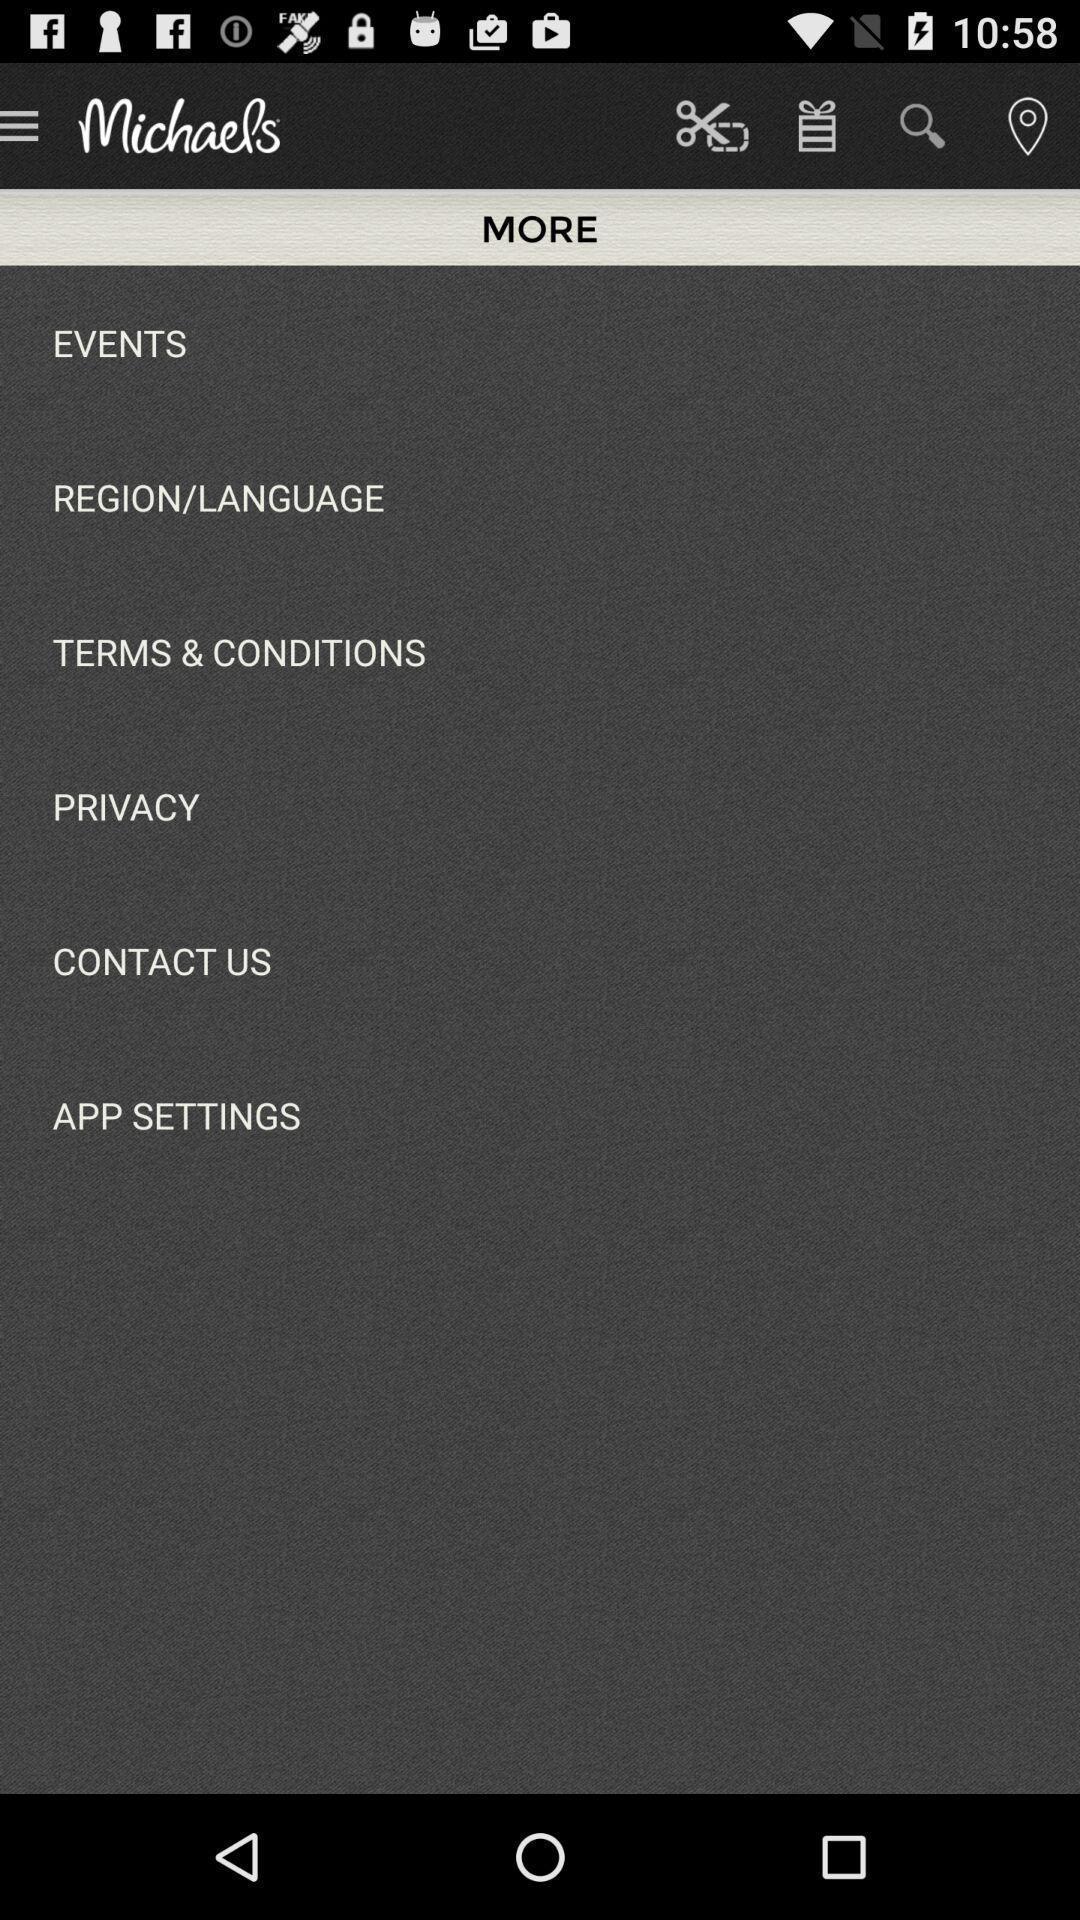Please provide a description for this image. Page showing options arel shopping app. 